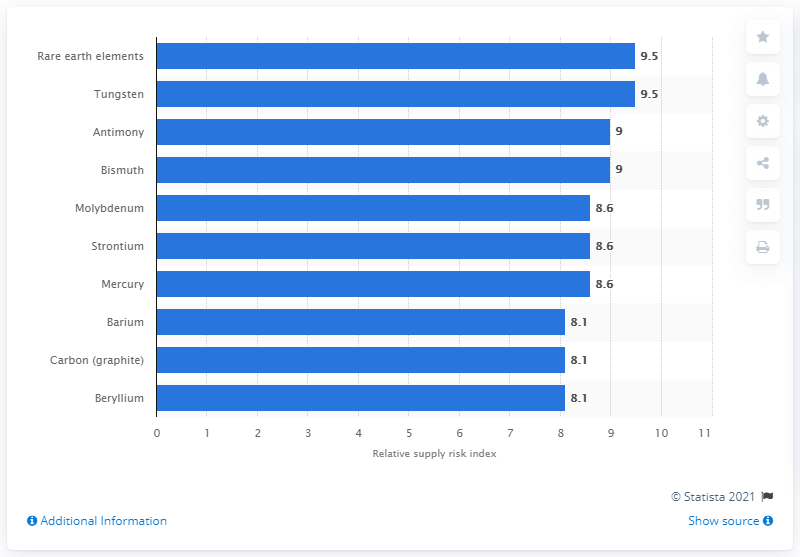Specify some key components in this picture. The relative supply risk for molybdenum is 8.6%. 